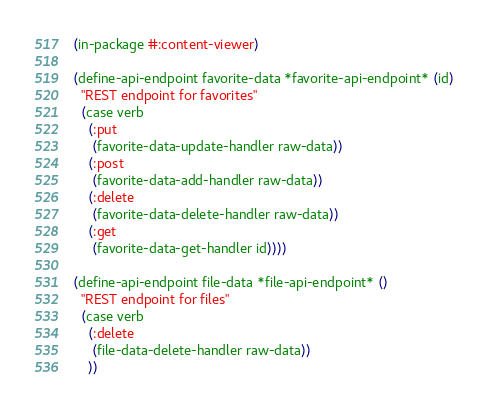<code> <loc_0><loc_0><loc_500><loc_500><_Lisp_>(in-package #:content-viewer)

(define-api-endpoint favorite-data *favorite-api-endpoint* (id)
  "REST endpoint for favorites"
  (case verb
    (:put
     (favorite-data-update-handler raw-data))
    (:post
     (favorite-data-add-handler raw-data))
    (:delete
     (favorite-data-delete-handler raw-data))
    (:get
     (favorite-data-get-handler id))))

(define-api-endpoint file-data *file-api-endpoint* ()
  "REST endpoint for files"
  (case verb
    (:delete
     (file-data-delete-handler raw-data))
    ))


</code> 